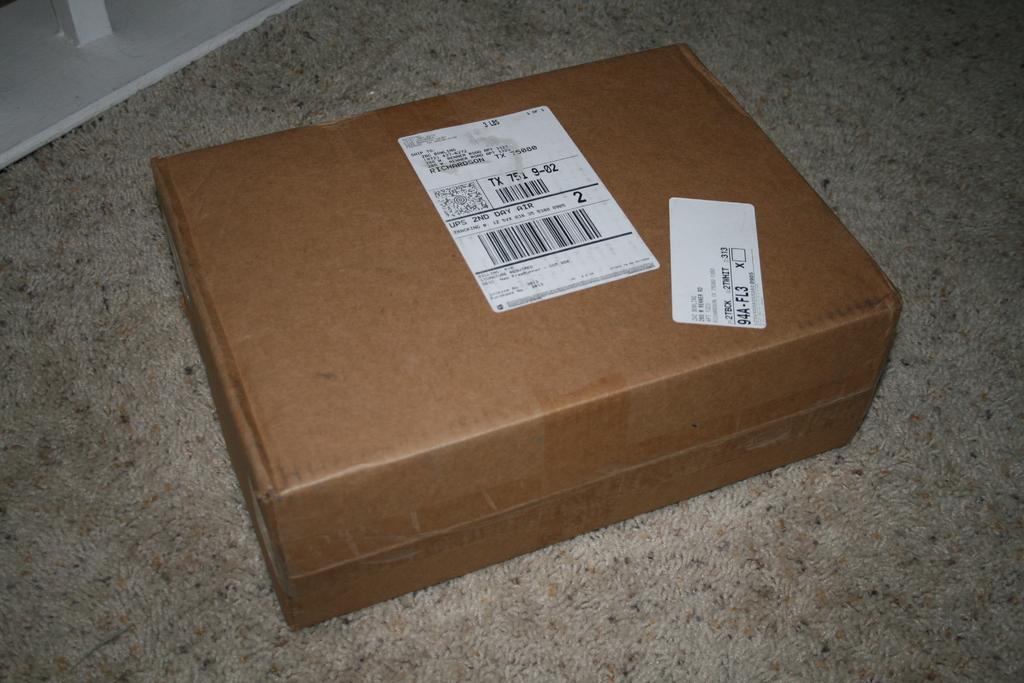How fast is the delivery time for this parcel?
Your answer should be compact. 2nd day. What single number is the largest print on the box?
Keep it short and to the point. 2. 